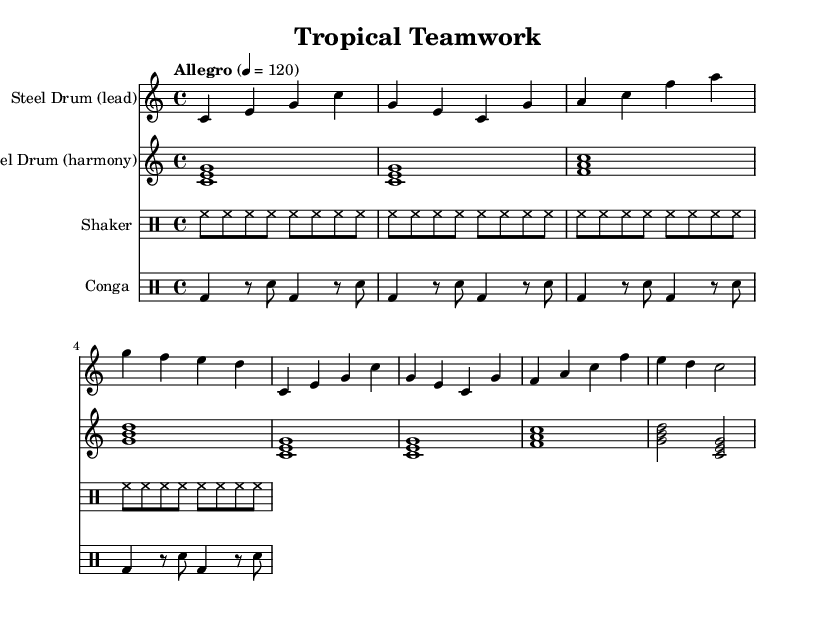What is the key signature of this music? The key signature is C major, which has no sharps or flats indicated in the music.
Answer: C major What is the time signature used in this piece? The time signature shown in the music indicates there are four beats per measure, denoted as 4/4.
Answer: 4/4 What is the tempo marked for this composition? The tempo marking indicates a fast pace, specifically "Allegro" at a metronome marking of 120 beats per minute.
Answer: Allegro 4 = 120 How many measures are in the lead steel drum part? By counting the grouped sets of musical notes, there are a total of eight measures in the lead steel drum part.
Answer: 8 What are the instruments used in this music? The score specifies three instruments: the lead steel drum, harmony steel drum, and two percussion parts (shaker and conga).
Answer: Steel Drum (lead), Steel Drum (harmony), Shaker, Conga Which rhythmic pattern is used for the shaker? The shaker plays a constant high-hat sound, indicated by the repeating eight notes in the sheet music, which is a standard shaker pattern.
Answer: High-hat What type of music does this piece represent? The music incorporates elements from Caribbean cultures specifically through the use of steel drums, aligning with the characteristics of World Music.
Answer: Caribbean 